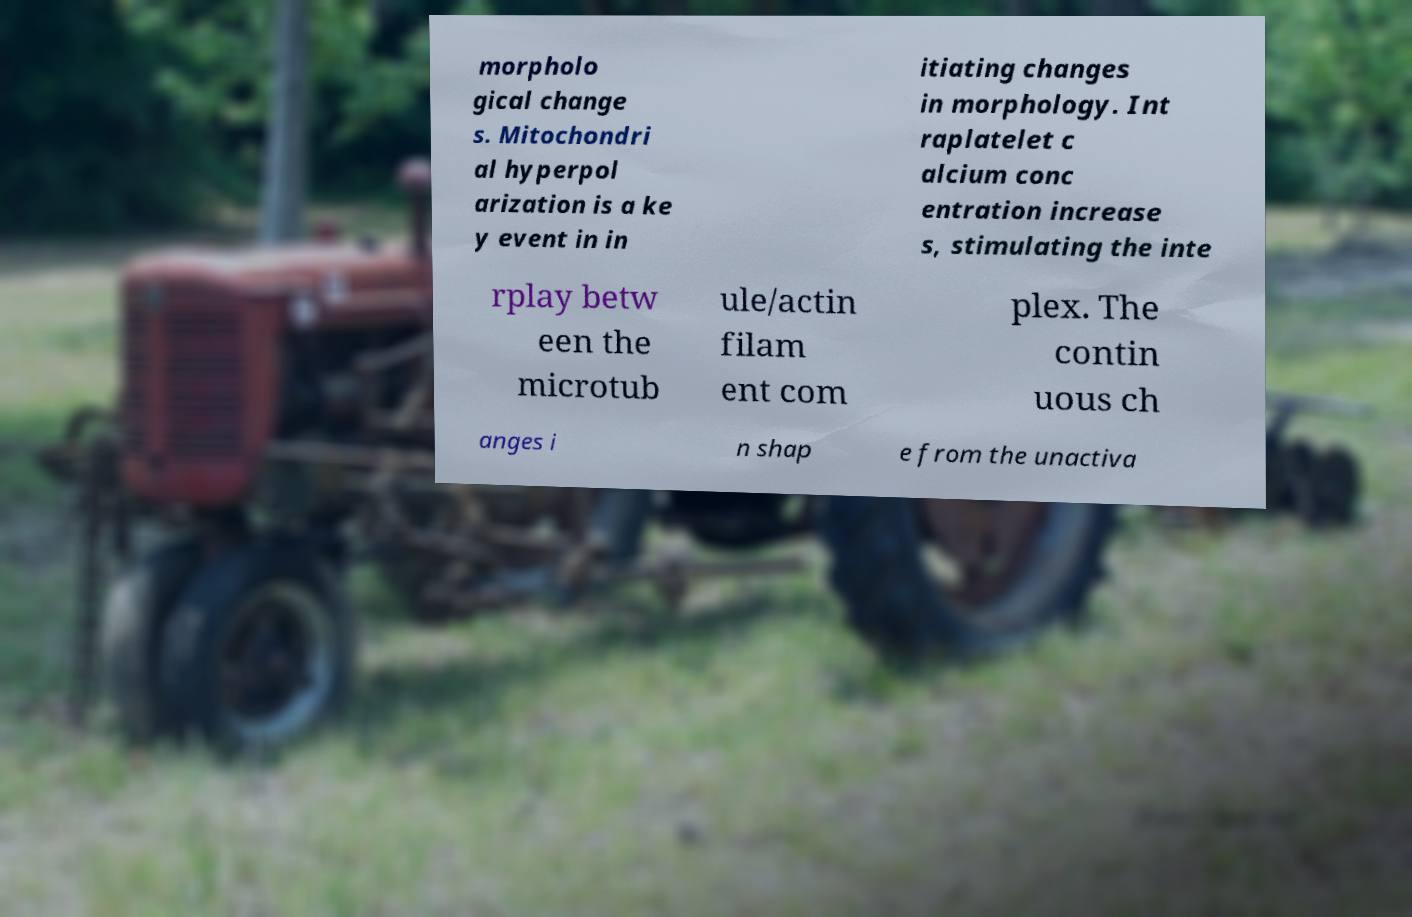I need the written content from this picture converted into text. Can you do that? morpholo gical change s. Mitochondri al hyperpol arization is a ke y event in in itiating changes in morphology. Int raplatelet c alcium conc entration increase s, stimulating the inte rplay betw een the microtub ule/actin filam ent com plex. The contin uous ch anges i n shap e from the unactiva 